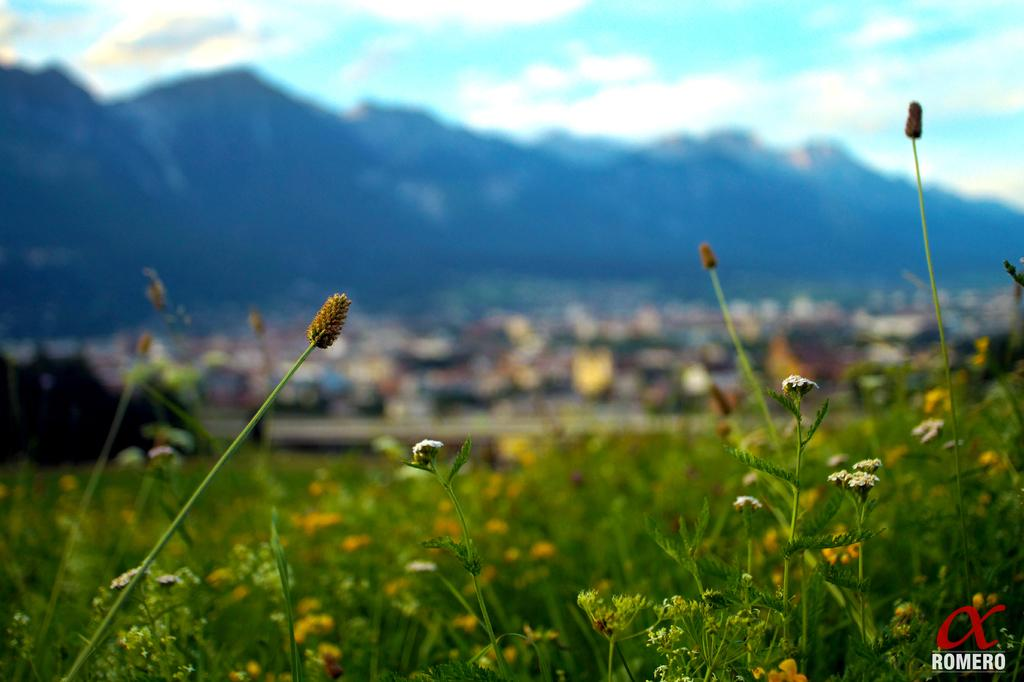What types of living organisms can be seen in the image? Plants and flowers are visible in the image. What is the condition of the background in the image? The background of the image is blurred. What natural landmark can be seen in the image? There is a mountain visible in the image. What part of the natural environment is visible in the image? The sky is visible in the image, and clouds are present in the sky. Is there any text present in the image? Yes, there is text written at the bottom of the image. What type of thrill can be experienced by the camera in the image? There is no camera present in the image, so it is not possible to determine what type of thrill might be experienced. 